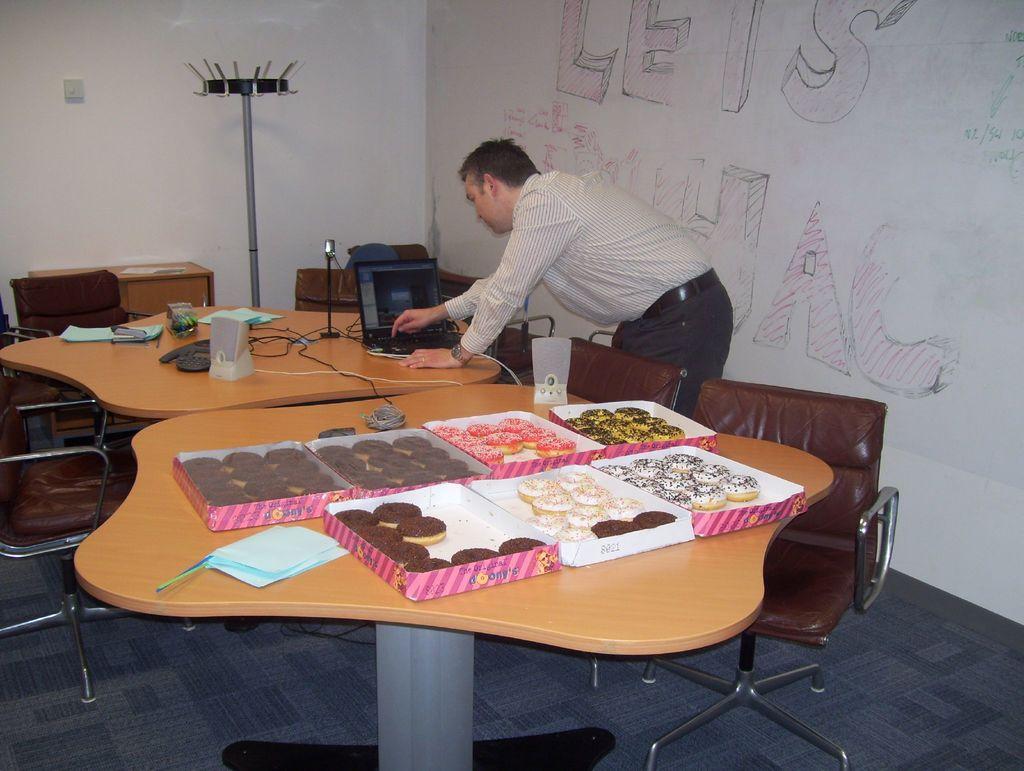How would you summarize this image in a sentence or two? there are 2 tables. on the front table there are 7 boxes of donuts. on the right and left there are chairs. there is a person at the back who is operating a laptop. at the back there is a white wall. 